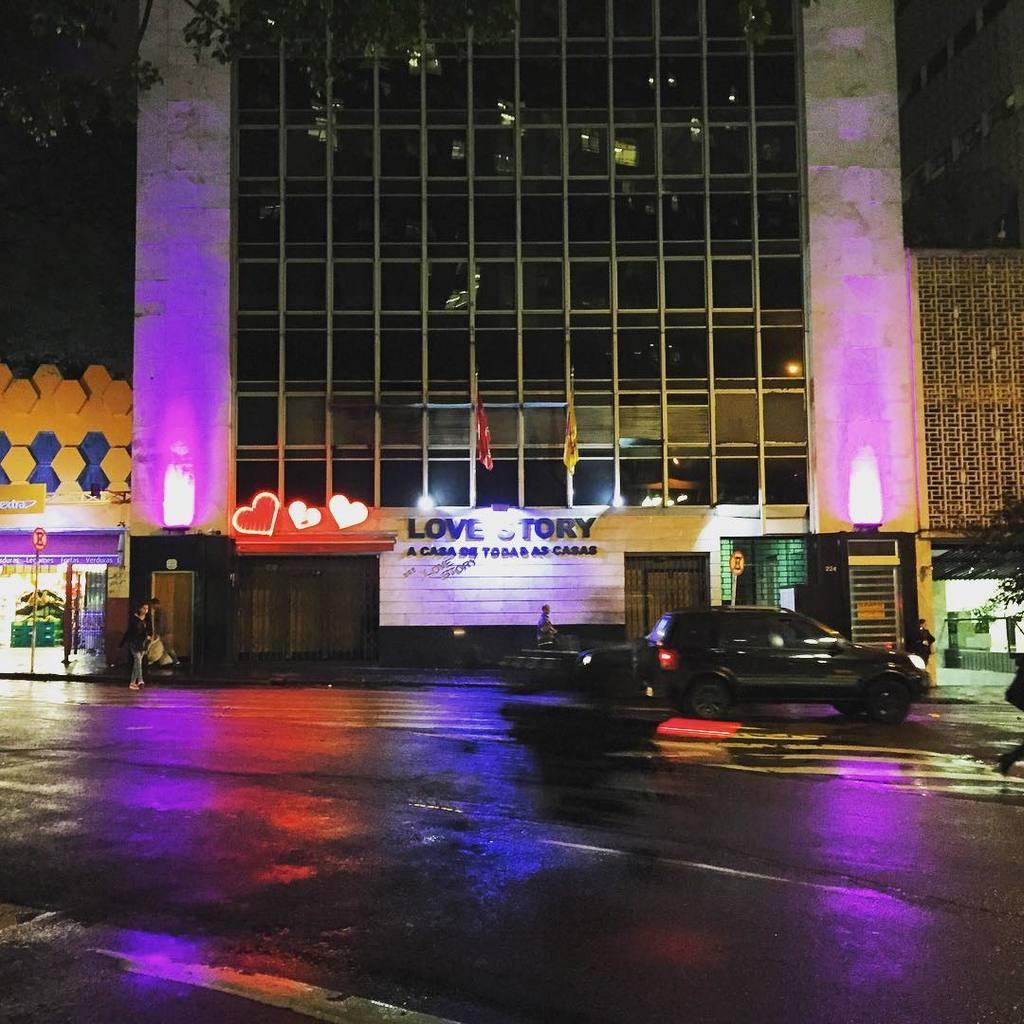Describe this image in one or two sentences. In this image we can see the building and glass windows, near that we can see the flags, after that we can see some written text on the board, on the right we can see a plant in a pot, we can see people, we can see the vehicle on the road. 